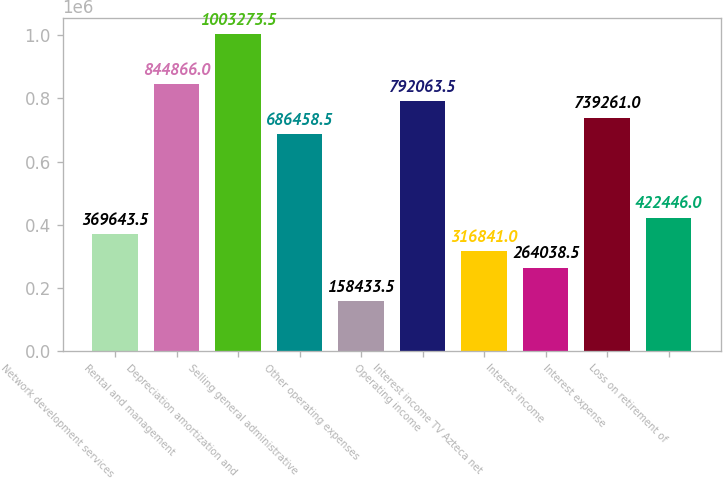Convert chart to OTSL. <chart><loc_0><loc_0><loc_500><loc_500><bar_chart><fcel>Network development services<fcel>Rental and management<fcel>Depreciation amortization and<fcel>Selling general administrative<fcel>Other operating expenses<fcel>Operating income<fcel>Interest income TV Azteca net<fcel>Interest income<fcel>Interest expense<fcel>Loss on retirement of<nl><fcel>369644<fcel>844866<fcel>1.00327e+06<fcel>686458<fcel>158434<fcel>792064<fcel>316841<fcel>264038<fcel>739261<fcel>422446<nl></chart> 